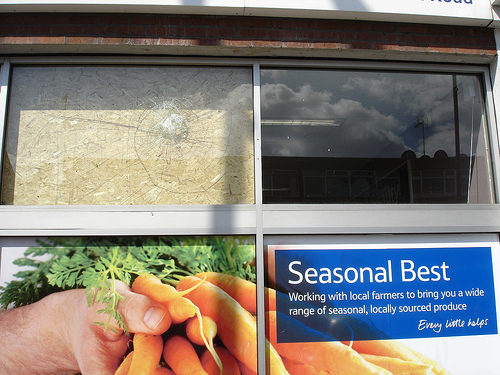<image>
Can you confirm if the thumb is on the carrot? Yes. Looking at the image, I can see the thumb is positioned on top of the carrot, with the carrot providing support. 